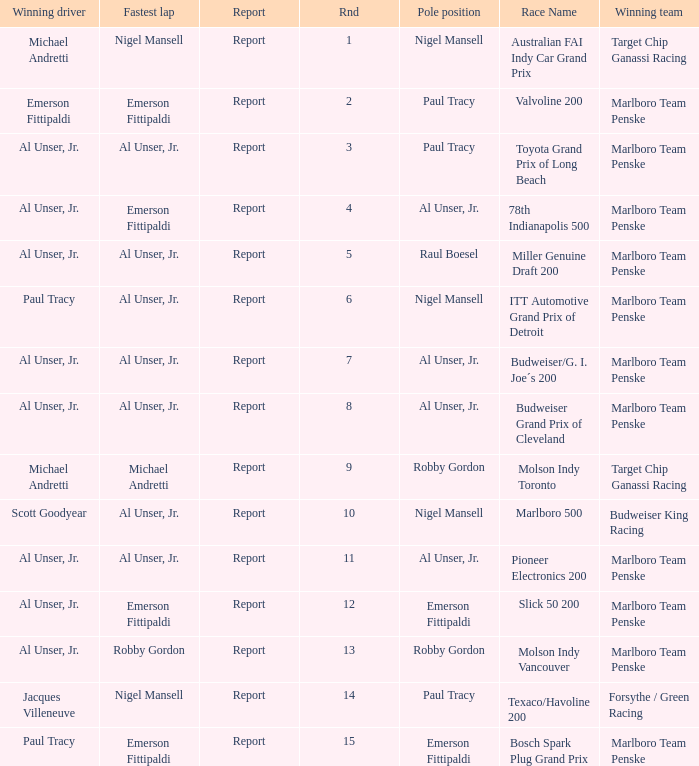Who was on the pole position in the Texaco/Havoline 200 race? Paul Tracy. 